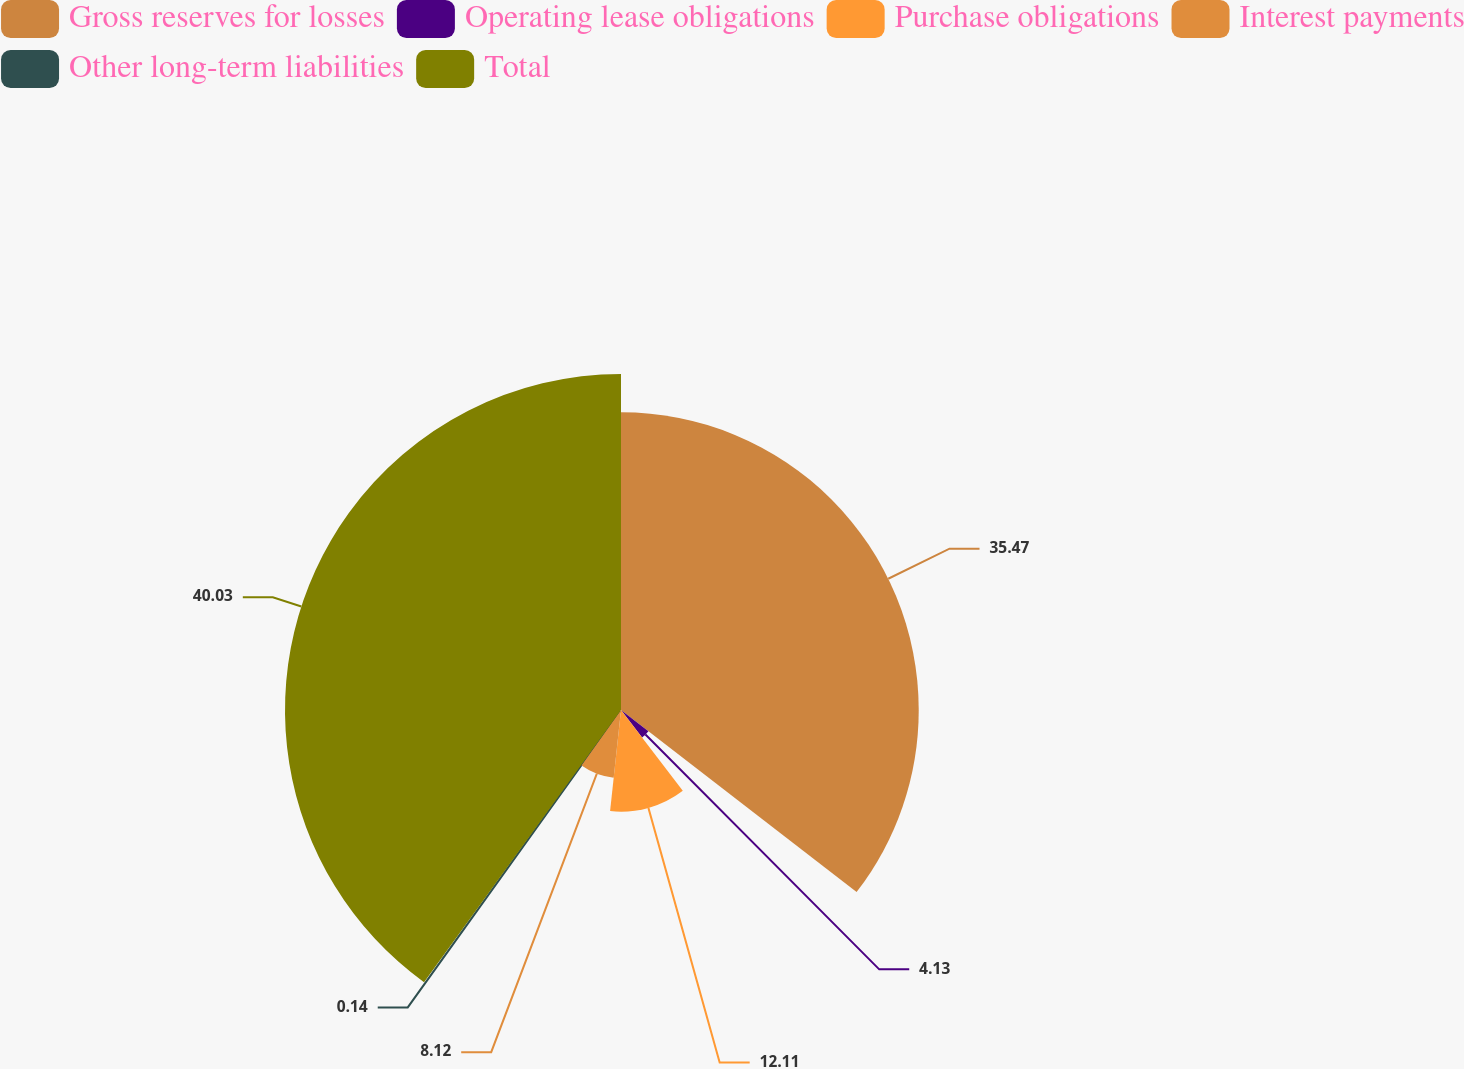<chart> <loc_0><loc_0><loc_500><loc_500><pie_chart><fcel>Gross reserves for losses<fcel>Operating lease obligations<fcel>Purchase obligations<fcel>Interest payments<fcel>Other long-term liabilities<fcel>Total<nl><fcel>35.47%<fcel>4.13%<fcel>12.11%<fcel>8.12%<fcel>0.14%<fcel>40.03%<nl></chart> 